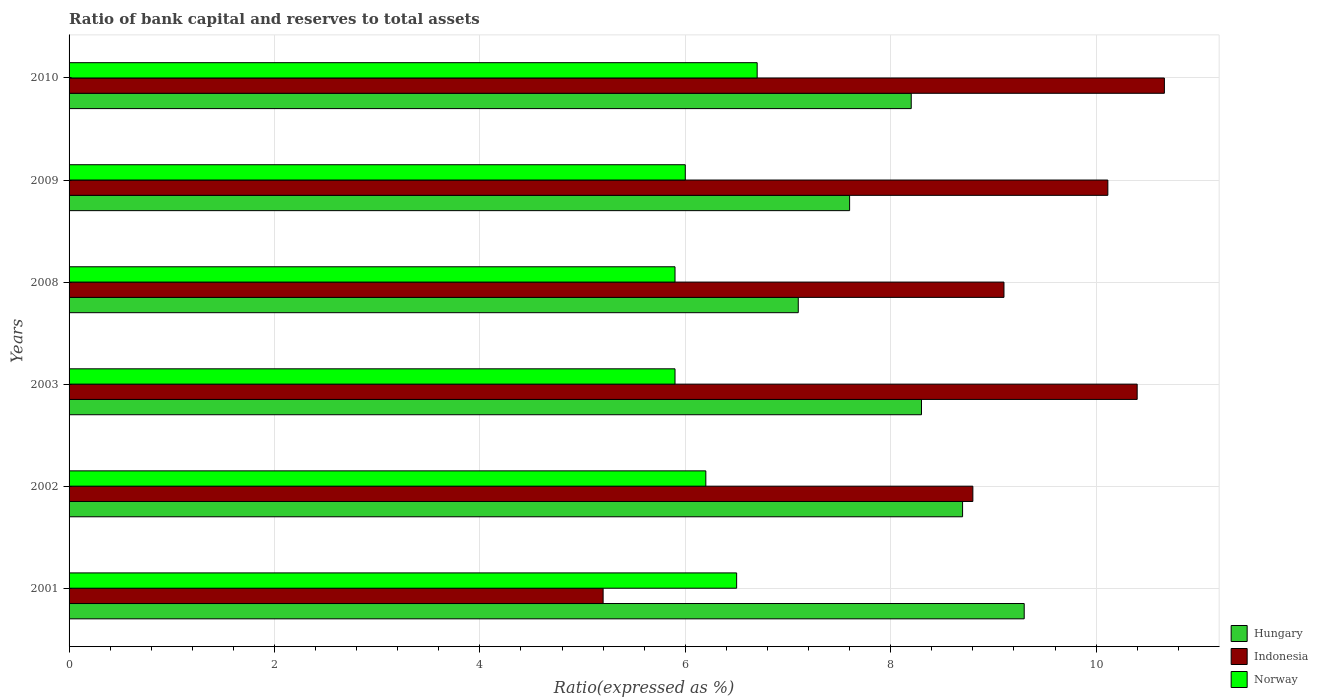How many different coloured bars are there?
Offer a terse response. 3. How many groups of bars are there?
Make the answer very short. 6. Are the number of bars on each tick of the Y-axis equal?
Offer a terse response. Yes. How many bars are there on the 2nd tick from the bottom?
Your response must be concise. 3. In how many cases, is the number of bars for a given year not equal to the number of legend labels?
Your response must be concise. 0. What is the ratio of bank capital and reserves to total assets in Indonesia in 2003?
Provide a succinct answer. 10.4. Across all years, what is the minimum ratio of bank capital and reserves to total assets in Norway?
Your answer should be very brief. 5.9. What is the total ratio of bank capital and reserves to total assets in Hungary in the graph?
Offer a terse response. 49.2. What is the difference between the ratio of bank capital and reserves to total assets in Norway in 2002 and that in 2003?
Your answer should be very brief. 0.3. What is the difference between the ratio of bank capital and reserves to total assets in Hungary in 2009 and the ratio of bank capital and reserves to total assets in Indonesia in 2002?
Your response must be concise. -1.2. What is the average ratio of bank capital and reserves to total assets in Indonesia per year?
Give a very brief answer. 9.05. In the year 2003, what is the difference between the ratio of bank capital and reserves to total assets in Norway and ratio of bank capital and reserves to total assets in Hungary?
Ensure brevity in your answer.  -2.4. In how many years, is the ratio of bank capital and reserves to total assets in Norway greater than 10.4 %?
Your response must be concise. 0. What is the ratio of the ratio of bank capital and reserves to total assets in Hungary in 2008 to that in 2009?
Your answer should be very brief. 0.93. Is the difference between the ratio of bank capital and reserves to total assets in Norway in 2002 and 2010 greater than the difference between the ratio of bank capital and reserves to total assets in Hungary in 2002 and 2010?
Provide a succinct answer. No. What is the difference between the highest and the second highest ratio of bank capital and reserves to total assets in Norway?
Offer a terse response. 0.2. What is the difference between the highest and the lowest ratio of bank capital and reserves to total assets in Norway?
Offer a very short reply. 0.8. Is the sum of the ratio of bank capital and reserves to total assets in Indonesia in 2003 and 2010 greater than the maximum ratio of bank capital and reserves to total assets in Norway across all years?
Offer a terse response. Yes. What does the 2nd bar from the top in 2009 represents?
Keep it short and to the point. Indonesia. What does the 1st bar from the bottom in 2010 represents?
Your answer should be very brief. Hungary. How many years are there in the graph?
Your answer should be compact. 6. Are the values on the major ticks of X-axis written in scientific E-notation?
Give a very brief answer. No. Does the graph contain grids?
Offer a terse response. Yes. Where does the legend appear in the graph?
Offer a very short reply. Bottom right. How many legend labels are there?
Offer a very short reply. 3. What is the title of the graph?
Ensure brevity in your answer.  Ratio of bank capital and reserves to total assets. What is the label or title of the X-axis?
Provide a succinct answer. Ratio(expressed as %). What is the label or title of the Y-axis?
Provide a succinct answer. Years. What is the Ratio(expressed as %) in Hungary in 2001?
Offer a very short reply. 9.3. What is the Ratio(expressed as %) in Indonesia in 2001?
Provide a short and direct response. 5.2. What is the Ratio(expressed as %) of Indonesia in 2002?
Keep it short and to the point. 8.8. What is the Ratio(expressed as %) of Hungary in 2003?
Ensure brevity in your answer.  8.3. What is the Ratio(expressed as %) in Indonesia in 2003?
Offer a terse response. 10.4. What is the Ratio(expressed as %) in Norway in 2003?
Ensure brevity in your answer.  5.9. What is the Ratio(expressed as %) in Indonesia in 2008?
Ensure brevity in your answer.  9.1. What is the Ratio(expressed as %) of Indonesia in 2009?
Your response must be concise. 10.11. What is the Ratio(expressed as %) of Norway in 2009?
Provide a succinct answer. 6. What is the Ratio(expressed as %) in Indonesia in 2010?
Provide a succinct answer. 10.66. What is the Ratio(expressed as %) of Norway in 2010?
Provide a succinct answer. 6.7. Across all years, what is the maximum Ratio(expressed as %) in Indonesia?
Provide a succinct answer. 10.66. Across all years, what is the maximum Ratio(expressed as %) of Norway?
Keep it short and to the point. 6.7. Across all years, what is the minimum Ratio(expressed as %) of Hungary?
Your response must be concise. 7.1. Across all years, what is the minimum Ratio(expressed as %) in Norway?
Give a very brief answer. 5.9. What is the total Ratio(expressed as %) in Hungary in the graph?
Ensure brevity in your answer.  49.2. What is the total Ratio(expressed as %) in Indonesia in the graph?
Ensure brevity in your answer.  54.28. What is the total Ratio(expressed as %) of Norway in the graph?
Your answer should be very brief. 37.2. What is the difference between the Ratio(expressed as %) in Indonesia in 2001 and that in 2002?
Provide a succinct answer. -3.6. What is the difference between the Ratio(expressed as %) of Norway in 2001 and that in 2002?
Your response must be concise. 0.3. What is the difference between the Ratio(expressed as %) of Indonesia in 2001 and that in 2008?
Offer a terse response. -3.9. What is the difference between the Ratio(expressed as %) in Indonesia in 2001 and that in 2009?
Your response must be concise. -4.91. What is the difference between the Ratio(expressed as %) of Indonesia in 2001 and that in 2010?
Keep it short and to the point. -5.46. What is the difference between the Ratio(expressed as %) of Hungary in 2002 and that in 2003?
Keep it short and to the point. 0.4. What is the difference between the Ratio(expressed as %) in Hungary in 2002 and that in 2008?
Keep it short and to the point. 1.6. What is the difference between the Ratio(expressed as %) in Indonesia in 2002 and that in 2008?
Keep it short and to the point. -0.3. What is the difference between the Ratio(expressed as %) in Hungary in 2002 and that in 2009?
Provide a short and direct response. 1.1. What is the difference between the Ratio(expressed as %) in Indonesia in 2002 and that in 2009?
Provide a short and direct response. -1.31. What is the difference between the Ratio(expressed as %) of Indonesia in 2002 and that in 2010?
Your response must be concise. -1.86. What is the difference between the Ratio(expressed as %) of Hungary in 2003 and that in 2008?
Keep it short and to the point. 1.2. What is the difference between the Ratio(expressed as %) of Indonesia in 2003 and that in 2008?
Make the answer very short. 1.3. What is the difference between the Ratio(expressed as %) of Norway in 2003 and that in 2008?
Your response must be concise. 0. What is the difference between the Ratio(expressed as %) of Hungary in 2003 and that in 2009?
Your answer should be compact. 0.7. What is the difference between the Ratio(expressed as %) of Indonesia in 2003 and that in 2009?
Offer a terse response. 0.29. What is the difference between the Ratio(expressed as %) in Hungary in 2003 and that in 2010?
Keep it short and to the point. 0.1. What is the difference between the Ratio(expressed as %) in Indonesia in 2003 and that in 2010?
Your answer should be compact. -0.26. What is the difference between the Ratio(expressed as %) of Hungary in 2008 and that in 2009?
Your answer should be compact. -0.5. What is the difference between the Ratio(expressed as %) of Indonesia in 2008 and that in 2009?
Keep it short and to the point. -1.01. What is the difference between the Ratio(expressed as %) of Hungary in 2008 and that in 2010?
Your answer should be compact. -1.1. What is the difference between the Ratio(expressed as %) in Indonesia in 2008 and that in 2010?
Your response must be concise. -1.56. What is the difference between the Ratio(expressed as %) in Hungary in 2009 and that in 2010?
Your answer should be compact. -0.6. What is the difference between the Ratio(expressed as %) of Indonesia in 2009 and that in 2010?
Offer a very short reply. -0.55. What is the difference between the Ratio(expressed as %) of Hungary in 2001 and the Ratio(expressed as %) of Norway in 2002?
Give a very brief answer. 3.1. What is the difference between the Ratio(expressed as %) of Indonesia in 2001 and the Ratio(expressed as %) of Norway in 2002?
Your answer should be compact. -1. What is the difference between the Ratio(expressed as %) of Hungary in 2001 and the Ratio(expressed as %) of Indonesia in 2003?
Your response must be concise. -1.1. What is the difference between the Ratio(expressed as %) of Hungary in 2001 and the Ratio(expressed as %) of Norway in 2003?
Give a very brief answer. 3.4. What is the difference between the Ratio(expressed as %) in Hungary in 2001 and the Ratio(expressed as %) in Indonesia in 2008?
Keep it short and to the point. 0.2. What is the difference between the Ratio(expressed as %) of Hungary in 2001 and the Ratio(expressed as %) of Indonesia in 2009?
Make the answer very short. -0.81. What is the difference between the Ratio(expressed as %) in Hungary in 2001 and the Ratio(expressed as %) in Norway in 2009?
Make the answer very short. 3.3. What is the difference between the Ratio(expressed as %) in Indonesia in 2001 and the Ratio(expressed as %) in Norway in 2009?
Offer a very short reply. -0.8. What is the difference between the Ratio(expressed as %) in Hungary in 2001 and the Ratio(expressed as %) in Indonesia in 2010?
Your answer should be compact. -1.36. What is the difference between the Ratio(expressed as %) of Hungary in 2001 and the Ratio(expressed as %) of Norway in 2010?
Your answer should be compact. 2.6. What is the difference between the Ratio(expressed as %) in Indonesia in 2001 and the Ratio(expressed as %) in Norway in 2010?
Offer a terse response. -1.5. What is the difference between the Ratio(expressed as %) in Hungary in 2002 and the Ratio(expressed as %) in Indonesia in 2003?
Your response must be concise. -1.7. What is the difference between the Ratio(expressed as %) of Hungary in 2002 and the Ratio(expressed as %) of Norway in 2003?
Provide a succinct answer. 2.8. What is the difference between the Ratio(expressed as %) in Hungary in 2002 and the Ratio(expressed as %) in Indonesia in 2008?
Your answer should be compact. -0.4. What is the difference between the Ratio(expressed as %) in Hungary in 2002 and the Ratio(expressed as %) in Norway in 2008?
Provide a short and direct response. 2.8. What is the difference between the Ratio(expressed as %) of Indonesia in 2002 and the Ratio(expressed as %) of Norway in 2008?
Provide a short and direct response. 2.9. What is the difference between the Ratio(expressed as %) of Hungary in 2002 and the Ratio(expressed as %) of Indonesia in 2009?
Keep it short and to the point. -1.41. What is the difference between the Ratio(expressed as %) in Hungary in 2002 and the Ratio(expressed as %) in Indonesia in 2010?
Keep it short and to the point. -1.96. What is the difference between the Ratio(expressed as %) of Hungary in 2002 and the Ratio(expressed as %) of Norway in 2010?
Ensure brevity in your answer.  2. What is the difference between the Ratio(expressed as %) in Hungary in 2003 and the Ratio(expressed as %) in Indonesia in 2008?
Provide a short and direct response. -0.8. What is the difference between the Ratio(expressed as %) of Hungary in 2003 and the Ratio(expressed as %) of Indonesia in 2009?
Your answer should be very brief. -1.81. What is the difference between the Ratio(expressed as %) in Indonesia in 2003 and the Ratio(expressed as %) in Norway in 2009?
Provide a short and direct response. 4.4. What is the difference between the Ratio(expressed as %) in Hungary in 2003 and the Ratio(expressed as %) in Indonesia in 2010?
Keep it short and to the point. -2.36. What is the difference between the Ratio(expressed as %) of Hungary in 2003 and the Ratio(expressed as %) of Norway in 2010?
Offer a terse response. 1.6. What is the difference between the Ratio(expressed as %) of Hungary in 2008 and the Ratio(expressed as %) of Indonesia in 2009?
Your answer should be compact. -3.01. What is the difference between the Ratio(expressed as %) of Hungary in 2008 and the Ratio(expressed as %) of Norway in 2009?
Keep it short and to the point. 1.1. What is the difference between the Ratio(expressed as %) in Indonesia in 2008 and the Ratio(expressed as %) in Norway in 2009?
Your answer should be very brief. 3.1. What is the difference between the Ratio(expressed as %) of Hungary in 2008 and the Ratio(expressed as %) of Indonesia in 2010?
Give a very brief answer. -3.56. What is the difference between the Ratio(expressed as %) in Hungary in 2008 and the Ratio(expressed as %) in Norway in 2010?
Give a very brief answer. 0.4. What is the difference between the Ratio(expressed as %) of Indonesia in 2008 and the Ratio(expressed as %) of Norway in 2010?
Make the answer very short. 2.4. What is the difference between the Ratio(expressed as %) of Hungary in 2009 and the Ratio(expressed as %) of Indonesia in 2010?
Offer a very short reply. -3.06. What is the difference between the Ratio(expressed as %) of Hungary in 2009 and the Ratio(expressed as %) of Norway in 2010?
Offer a terse response. 0.9. What is the difference between the Ratio(expressed as %) in Indonesia in 2009 and the Ratio(expressed as %) in Norway in 2010?
Provide a succinct answer. 3.41. What is the average Ratio(expressed as %) in Hungary per year?
Keep it short and to the point. 8.2. What is the average Ratio(expressed as %) of Indonesia per year?
Offer a very short reply. 9.05. What is the average Ratio(expressed as %) in Norway per year?
Your answer should be compact. 6.2. In the year 2001, what is the difference between the Ratio(expressed as %) in Hungary and Ratio(expressed as %) in Indonesia?
Your answer should be compact. 4.1. In the year 2001, what is the difference between the Ratio(expressed as %) of Hungary and Ratio(expressed as %) of Norway?
Offer a very short reply. 2.8. In the year 2001, what is the difference between the Ratio(expressed as %) in Indonesia and Ratio(expressed as %) in Norway?
Make the answer very short. -1.3. In the year 2002, what is the difference between the Ratio(expressed as %) of Indonesia and Ratio(expressed as %) of Norway?
Your response must be concise. 2.6. In the year 2008, what is the difference between the Ratio(expressed as %) in Hungary and Ratio(expressed as %) in Indonesia?
Provide a succinct answer. -2. In the year 2008, what is the difference between the Ratio(expressed as %) of Indonesia and Ratio(expressed as %) of Norway?
Make the answer very short. 3.2. In the year 2009, what is the difference between the Ratio(expressed as %) in Hungary and Ratio(expressed as %) in Indonesia?
Offer a very short reply. -2.51. In the year 2009, what is the difference between the Ratio(expressed as %) in Indonesia and Ratio(expressed as %) in Norway?
Ensure brevity in your answer.  4.11. In the year 2010, what is the difference between the Ratio(expressed as %) in Hungary and Ratio(expressed as %) in Indonesia?
Your response must be concise. -2.46. In the year 2010, what is the difference between the Ratio(expressed as %) in Hungary and Ratio(expressed as %) in Norway?
Provide a succinct answer. 1.5. In the year 2010, what is the difference between the Ratio(expressed as %) in Indonesia and Ratio(expressed as %) in Norway?
Provide a succinct answer. 3.96. What is the ratio of the Ratio(expressed as %) of Hungary in 2001 to that in 2002?
Offer a terse response. 1.07. What is the ratio of the Ratio(expressed as %) in Indonesia in 2001 to that in 2002?
Ensure brevity in your answer.  0.59. What is the ratio of the Ratio(expressed as %) in Norway in 2001 to that in 2002?
Ensure brevity in your answer.  1.05. What is the ratio of the Ratio(expressed as %) in Hungary in 2001 to that in 2003?
Give a very brief answer. 1.12. What is the ratio of the Ratio(expressed as %) of Indonesia in 2001 to that in 2003?
Make the answer very short. 0.5. What is the ratio of the Ratio(expressed as %) in Norway in 2001 to that in 2003?
Ensure brevity in your answer.  1.1. What is the ratio of the Ratio(expressed as %) in Hungary in 2001 to that in 2008?
Keep it short and to the point. 1.31. What is the ratio of the Ratio(expressed as %) of Indonesia in 2001 to that in 2008?
Ensure brevity in your answer.  0.57. What is the ratio of the Ratio(expressed as %) in Norway in 2001 to that in 2008?
Your answer should be compact. 1.1. What is the ratio of the Ratio(expressed as %) of Hungary in 2001 to that in 2009?
Provide a succinct answer. 1.22. What is the ratio of the Ratio(expressed as %) in Indonesia in 2001 to that in 2009?
Your answer should be compact. 0.51. What is the ratio of the Ratio(expressed as %) in Hungary in 2001 to that in 2010?
Ensure brevity in your answer.  1.13. What is the ratio of the Ratio(expressed as %) in Indonesia in 2001 to that in 2010?
Provide a succinct answer. 0.49. What is the ratio of the Ratio(expressed as %) of Norway in 2001 to that in 2010?
Your answer should be compact. 0.97. What is the ratio of the Ratio(expressed as %) of Hungary in 2002 to that in 2003?
Keep it short and to the point. 1.05. What is the ratio of the Ratio(expressed as %) of Indonesia in 2002 to that in 2003?
Keep it short and to the point. 0.85. What is the ratio of the Ratio(expressed as %) in Norway in 2002 to that in 2003?
Offer a very short reply. 1.05. What is the ratio of the Ratio(expressed as %) in Hungary in 2002 to that in 2008?
Ensure brevity in your answer.  1.23. What is the ratio of the Ratio(expressed as %) in Indonesia in 2002 to that in 2008?
Give a very brief answer. 0.97. What is the ratio of the Ratio(expressed as %) in Norway in 2002 to that in 2008?
Offer a very short reply. 1.05. What is the ratio of the Ratio(expressed as %) of Hungary in 2002 to that in 2009?
Ensure brevity in your answer.  1.14. What is the ratio of the Ratio(expressed as %) in Indonesia in 2002 to that in 2009?
Keep it short and to the point. 0.87. What is the ratio of the Ratio(expressed as %) of Norway in 2002 to that in 2009?
Make the answer very short. 1.03. What is the ratio of the Ratio(expressed as %) of Hungary in 2002 to that in 2010?
Make the answer very short. 1.06. What is the ratio of the Ratio(expressed as %) of Indonesia in 2002 to that in 2010?
Keep it short and to the point. 0.83. What is the ratio of the Ratio(expressed as %) of Norway in 2002 to that in 2010?
Keep it short and to the point. 0.93. What is the ratio of the Ratio(expressed as %) in Hungary in 2003 to that in 2008?
Offer a very short reply. 1.17. What is the ratio of the Ratio(expressed as %) of Indonesia in 2003 to that in 2008?
Keep it short and to the point. 1.14. What is the ratio of the Ratio(expressed as %) of Hungary in 2003 to that in 2009?
Ensure brevity in your answer.  1.09. What is the ratio of the Ratio(expressed as %) in Indonesia in 2003 to that in 2009?
Your answer should be very brief. 1.03. What is the ratio of the Ratio(expressed as %) in Norway in 2003 to that in 2009?
Make the answer very short. 0.98. What is the ratio of the Ratio(expressed as %) in Hungary in 2003 to that in 2010?
Provide a short and direct response. 1.01. What is the ratio of the Ratio(expressed as %) of Indonesia in 2003 to that in 2010?
Your answer should be very brief. 0.98. What is the ratio of the Ratio(expressed as %) in Norway in 2003 to that in 2010?
Ensure brevity in your answer.  0.88. What is the ratio of the Ratio(expressed as %) of Hungary in 2008 to that in 2009?
Offer a terse response. 0.93. What is the ratio of the Ratio(expressed as %) of Norway in 2008 to that in 2009?
Provide a short and direct response. 0.98. What is the ratio of the Ratio(expressed as %) of Hungary in 2008 to that in 2010?
Make the answer very short. 0.87. What is the ratio of the Ratio(expressed as %) of Indonesia in 2008 to that in 2010?
Give a very brief answer. 0.85. What is the ratio of the Ratio(expressed as %) in Norway in 2008 to that in 2010?
Offer a terse response. 0.88. What is the ratio of the Ratio(expressed as %) of Hungary in 2009 to that in 2010?
Keep it short and to the point. 0.93. What is the ratio of the Ratio(expressed as %) in Indonesia in 2009 to that in 2010?
Your response must be concise. 0.95. What is the ratio of the Ratio(expressed as %) of Norway in 2009 to that in 2010?
Make the answer very short. 0.9. What is the difference between the highest and the second highest Ratio(expressed as %) in Indonesia?
Provide a succinct answer. 0.26. What is the difference between the highest and the lowest Ratio(expressed as %) in Hungary?
Provide a succinct answer. 2.2. What is the difference between the highest and the lowest Ratio(expressed as %) in Indonesia?
Keep it short and to the point. 5.46. What is the difference between the highest and the lowest Ratio(expressed as %) in Norway?
Keep it short and to the point. 0.8. 